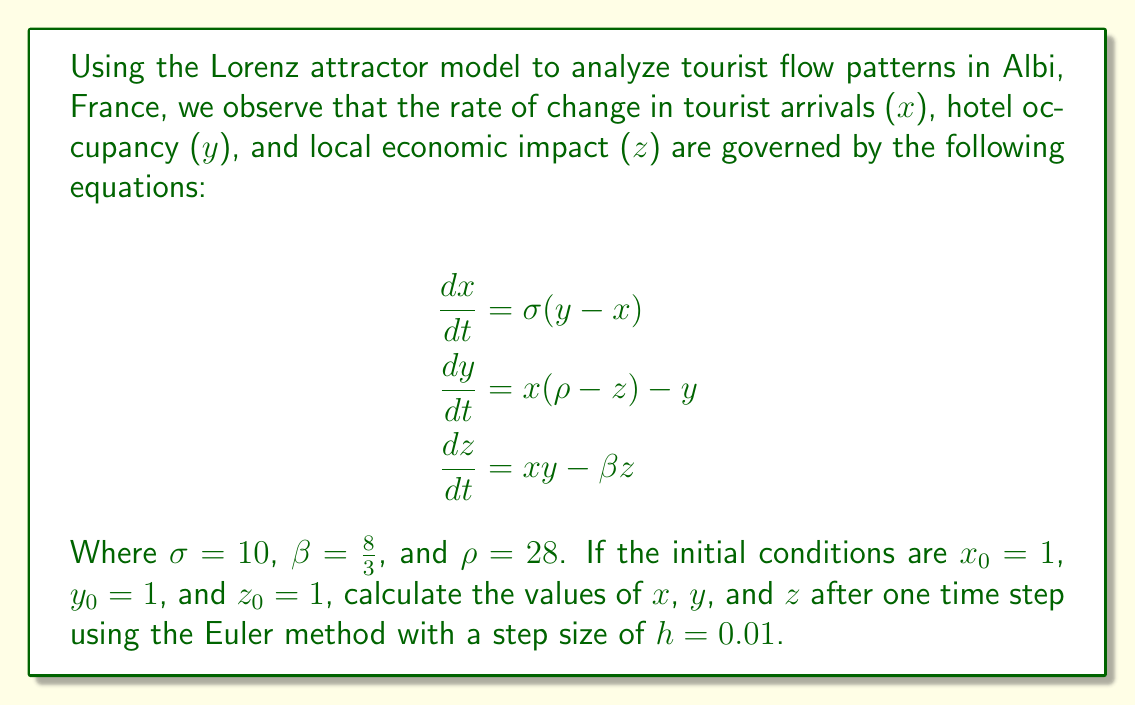Teach me how to tackle this problem. To solve this problem, we'll use the Euler method to approximate the solution of the Lorenz system. The Euler method is given by:

$$x_{n+1} = x_n + h \cdot f(x_n, y_n, z_n)$$
$$y_{n+1} = y_n + h \cdot g(x_n, y_n, z_n)$$
$$z_{n+1} = z_n + h \cdot k(x_n, y_n, z_n)$$

Where $f$, $g$, and $k$ are the right-hand sides of the Lorenz equations.

Step 1: Calculate $f(x_0, y_0, z_0)$
$$f(x_0, y_0, z_0) = \sigma(y_0 - x_0) = 10(1 - 1) = 0$$

Step 2: Calculate $g(x_0, y_0, z_0)$
$$g(x_0, y_0, z_0) = x_0(\rho - z_0) - y_0 = 1(28 - 1) - 1 = 26$$

Step 3: Calculate $k(x_0, y_0, z_0)$
$$k(x_0, y_0, z_0) = x_0y_0 - \beta z_0 = 1 \cdot 1 - \frac{8}{3} \cdot 1 = -\frac{5}{3}$$

Step 4: Apply the Euler method
$$x_1 = x_0 + h \cdot f(x_0, y_0, z_0) = 1 + 0.01 \cdot 0 = 1$$
$$y_1 = y_0 + h \cdot g(x_0, y_0, z_0) = 1 + 0.01 \cdot 26 = 1.26$$
$$z_1 = z_0 + h \cdot k(x_0, y_0, z_0) = 1 + 0.01 \cdot (-\frac{5}{3}) = 0.9833$$
Answer: $(1, 1.26, 0.9833)$ 